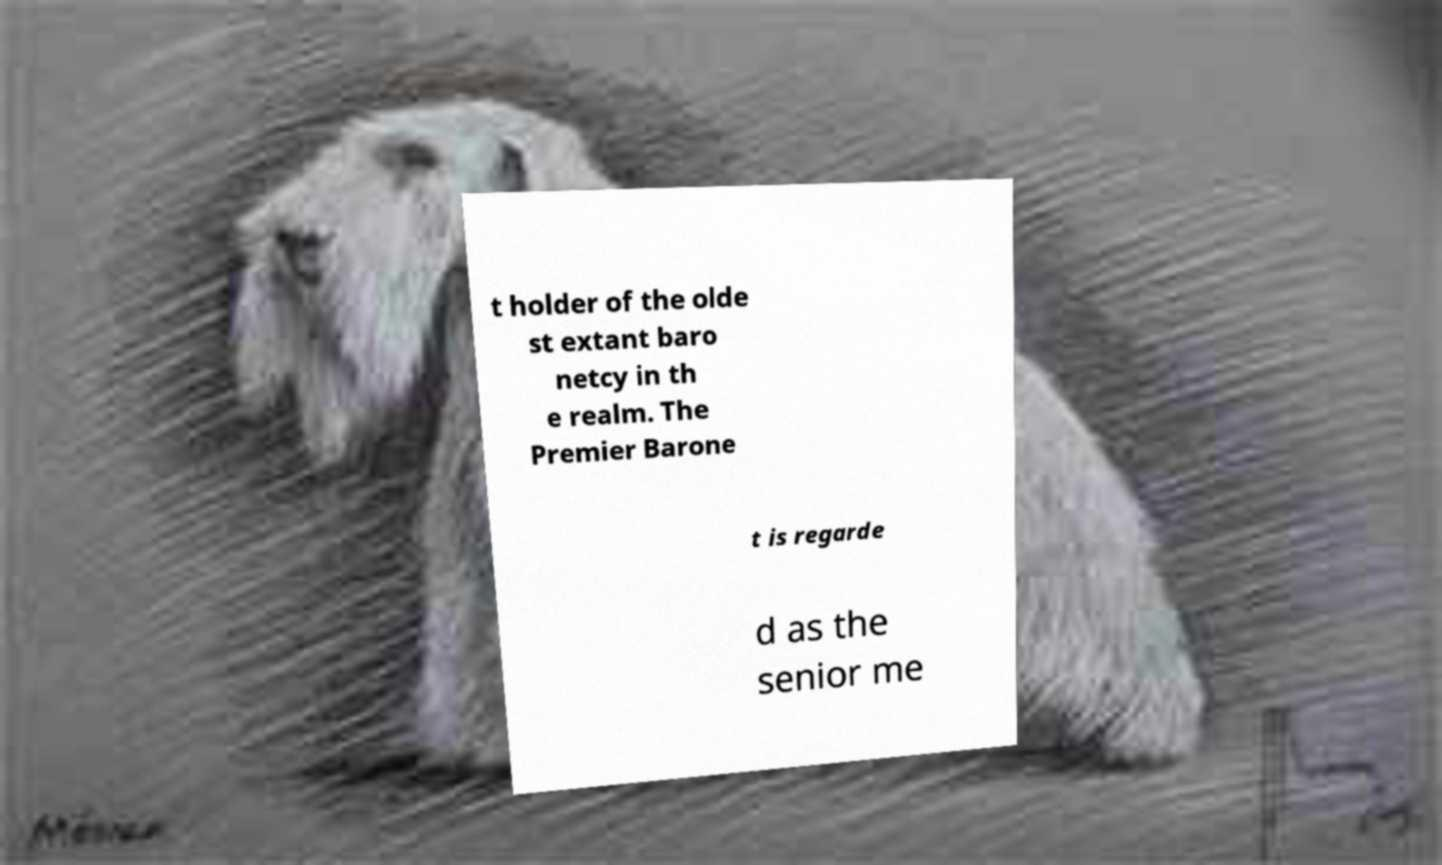There's text embedded in this image that I need extracted. Can you transcribe it verbatim? t holder of the olde st extant baro netcy in th e realm. The Premier Barone t is regarde d as the senior me 